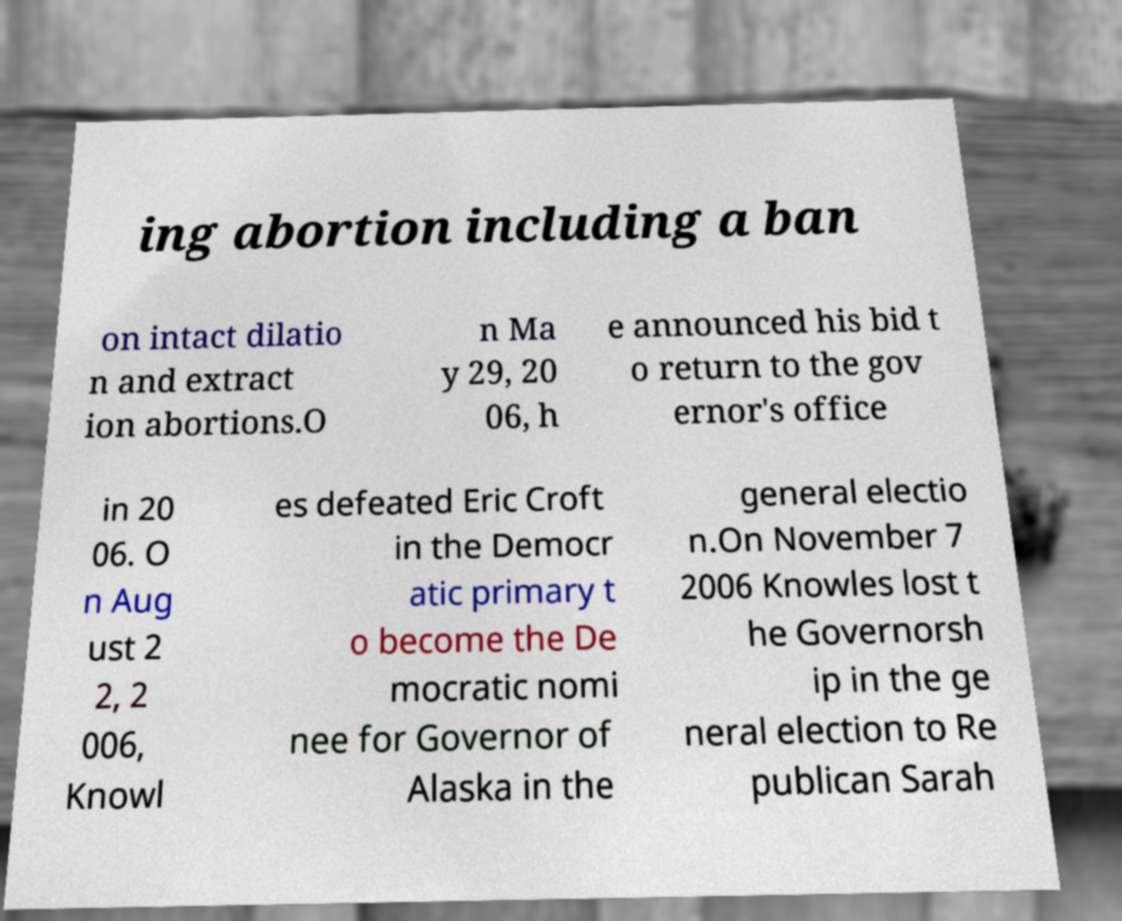For documentation purposes, I need the text within this image transcribed. Could you provide that? ing abortion including a ban on intact dilatio n and extract ion abortions.O n Ma y 29, 20 06, h e announced his bid t o return to the gov ernor's office in 20 06. O n Aug ust 2 2, 2 006, Knowl es defeated Eric Croft in the Democr atic primary t o become the De mocratic nomi nee for Governor of Alaska in the general electio n.On November 7 2006 Knowles lost t he Governorsh ip in the ge neral election to Re publican Sarah 